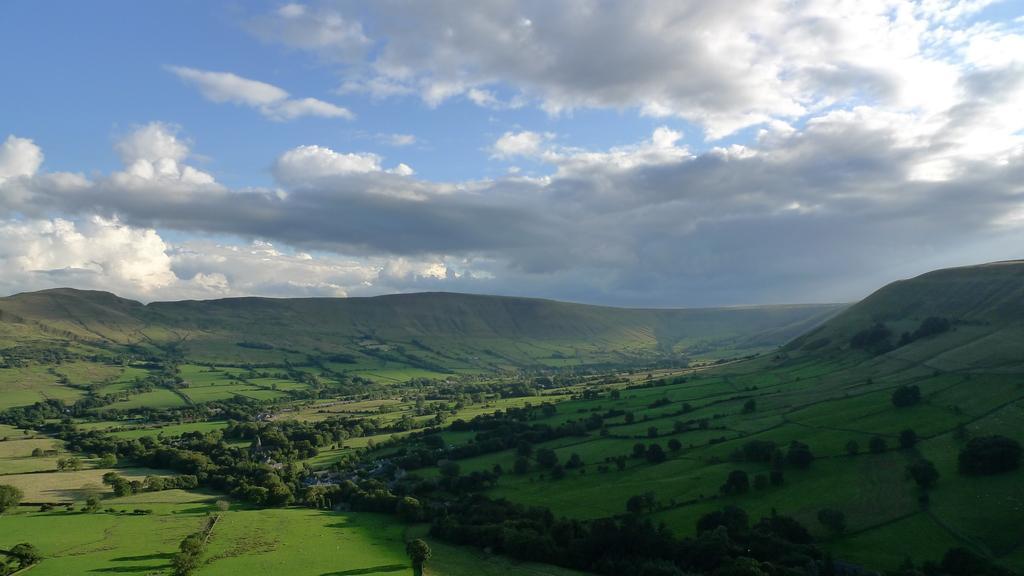Please provide a concise description of this image. This is grass and there are trees. In the background we can see sky with heavy clouds. 